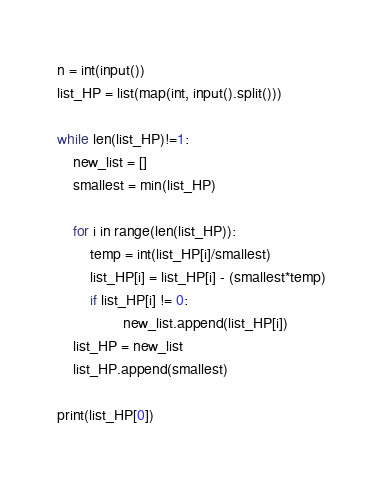<code> <loc_0><loc_0><loc_500><loc_500><_Python_>n = int(input())
list_HP = list(map(int, input().split()))

while len(list_HP)!=1:
	new_list = []
	smallest = min(list_HP)

	for i in range(len(list_HP)):
		temp = int(list_HP[i]/smallest)
		list_HP[i] = list_HP[i] - (smallest*temp)
		if list_HP[i] != 0:
				new_list.append(list_HP[i])
	list_HP = new_list
	list_HP.append(smallest)

print(list_HP[0])

</code> 